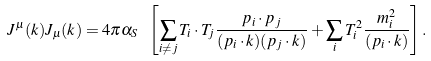<formula> <loc_0><loc_0><loc_500><loc_500>J ^ { \mu } ( k ) J _ { \mu } ( k ) = 4 \pi \alpha _ { S } \ \left [ \sum _ { i \not = j } T _ { i } \cdot T _ { j } \frac { p _ { i } \cdot p _ { j } } { ( p _ { i } \cdot k ) ( p _ { j } \cdot k ) } + \sum _ { i } T _ { i } ^ { 2 } \frac { m ^ { 2 } _ { i } } { ( p _ { i } \cdot k ) } \right ] .</formula> 